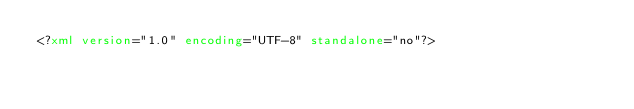<code> <loc_0><loc_0><loc_500><loc_500><_XML_><?xml version="1.0" encoding="UTF-8" standalone="no"?></code> 